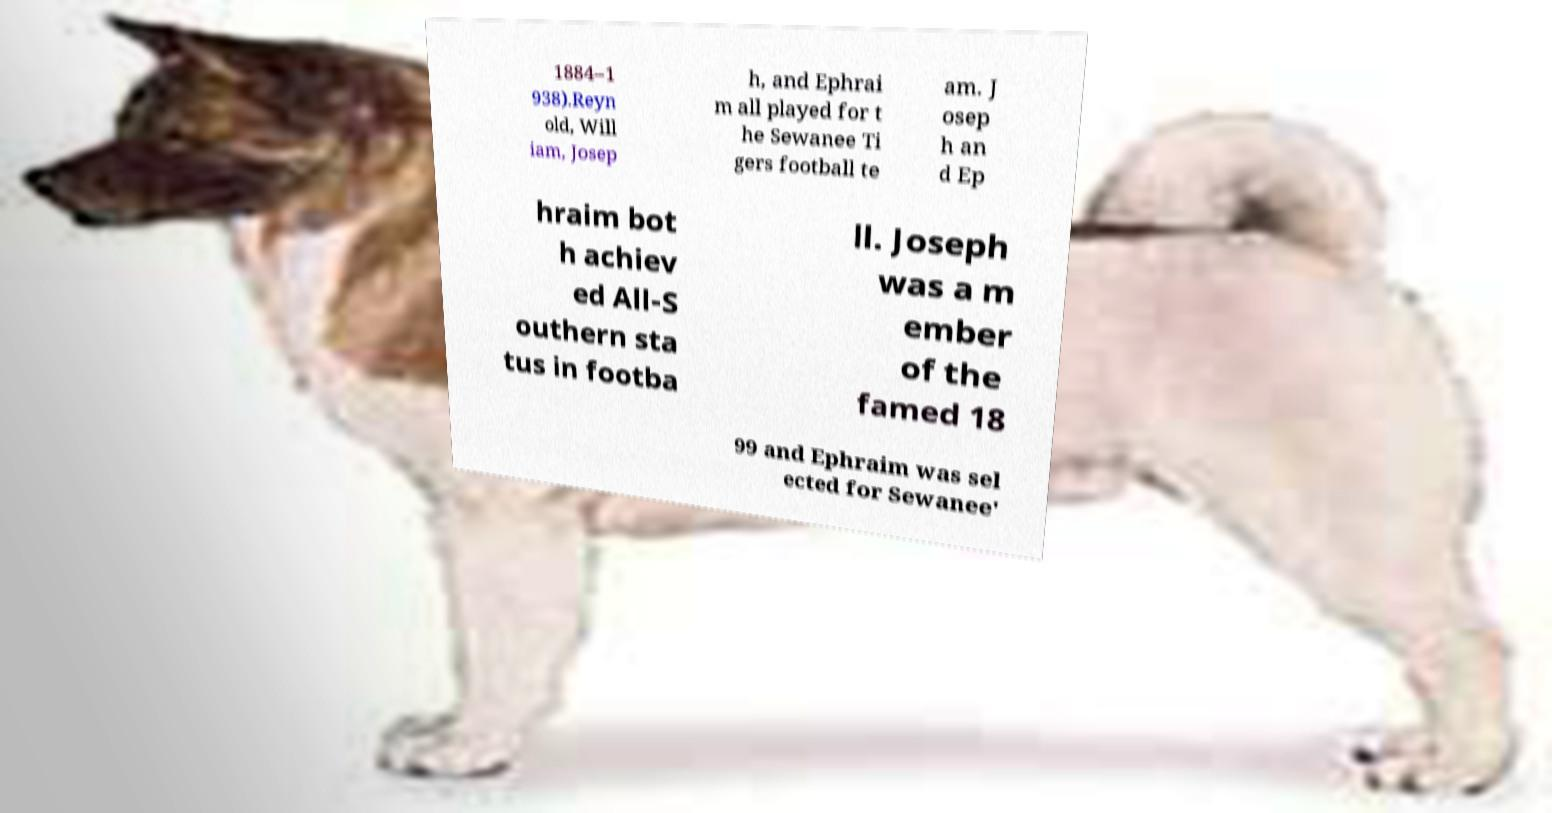Please identify and transcribe the text found in this image. 1884–1 938).Reyn old, Will iam, Josep h, and Ephrai m all played for t he Sewanee Ti gers football te am. J osep h an d Ep hraim bot h achiev ed All-S outhern sta tus in footba ll. Joseph was a m ember of the famed 18 99 and Ephraim was sel ected for Sewanee' 